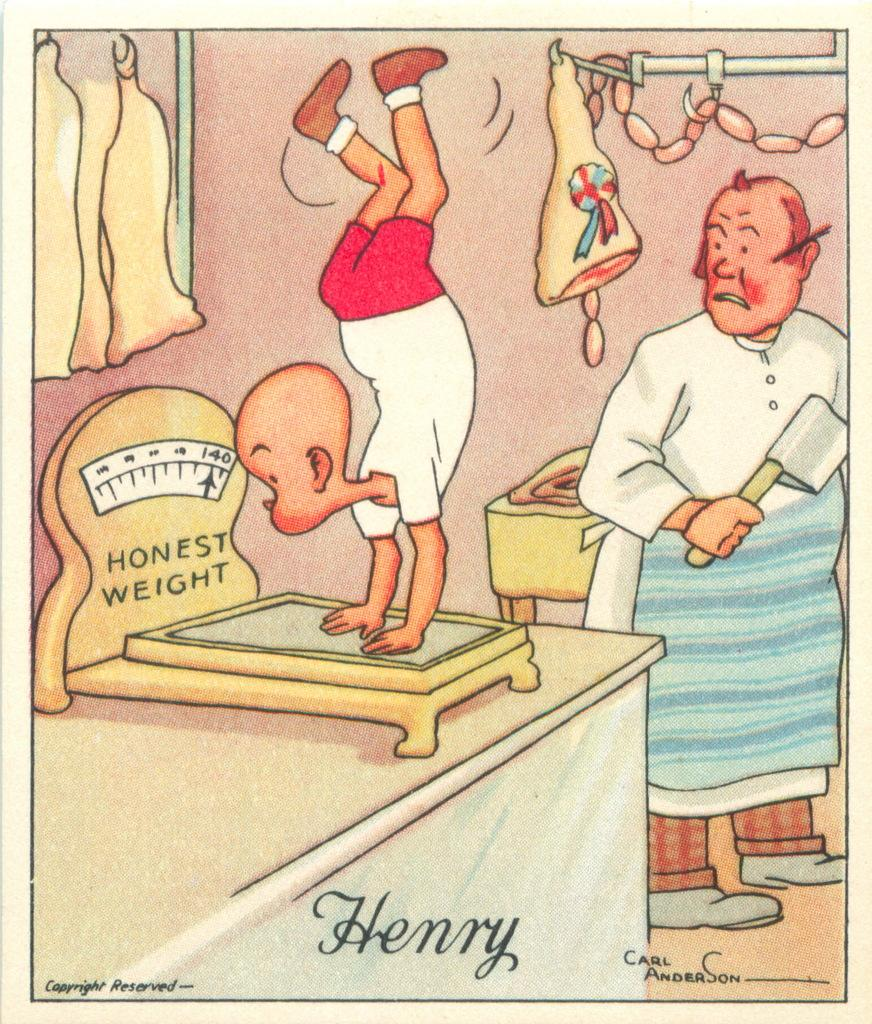What is depicted in the painting in the image? There is a painting of a wall in the image. What type of food can be seen in the image? There is meat in the image. What piece of furniture is present in the image? There is a table in the image. How many people are in the image? There are two people in the image. Where is the cactus located in the image? There is no cactus present in the image. What type of vessel is being used to cook the meat in the image? The image does not show any vessel being used to cook the meat; it only shows the meat itself. 